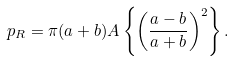Convert formula to latex. <formula><loc_0><loc_0><loc_500><loc_500>p _ { R } = \pi ( a + b ) A \left \{ \left ( \frac { a - b } { a + b } \right ) ^ { 2 } \right \} .</formula> 